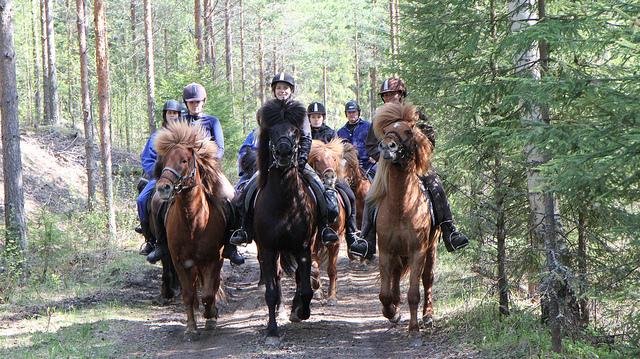What type of hats are they wearing?
Be succinct. Helmets. Are these people in the city?
Short answer required. No. Are they going on a hunting trip?
Answer briefly. No. What are these people riding?
Concise answer only. Horses. How many horses are in the picture?
Short answer required. 6. 